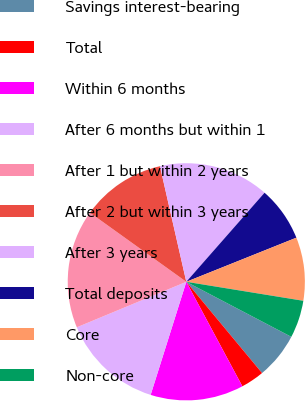<chart> <loc_0><loc_0><loc_500><loc_500><pie_chart><fcel>Savings interest-bearing<fcel>Total<fcel>Within 6 months<fcel>After 6 months but within 1<fcel>After 1 but within 2 years<fcel>After 2 but within 3 years<fcel>After 3 years<fcel>Total deposits<fcel>Core<fcel>Non-core<nl><fcel>6.29%<fcel>3.19%<fcel>12.7%<fcel>13.87%<fcel>16.17%<fcel>11.53%<fcel>15.04%<fcel>7.46%<fcel>8.63%<fcel>5.12%<nl></chart> 